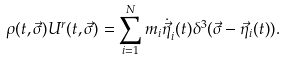<formula> <loc_0><loc_0><loc_500><loc_500>\rho ( t , \vec { \sigma } ) U ^ { r } ( t , \vec { \sigma } ) = \sum _ { i = 1 } ^ { N } m _ { i } { \dot { \vec { \eta } } } _ { i } ( t ) \delta ^ { 3 } ( \vec { \sigma } - { \vec { \eta } } _ { i } ( t ) ) .</formula> 